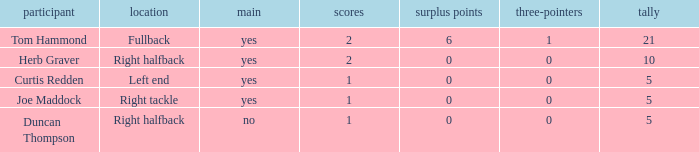I'm looking to parse the entire table for insights. Could you assist me with that? {'header': ['participant', 'location', 'main', 'scores', 'surplus points', 'three-pointers', 'tally'], 'rows': [['Tom Hammond', 'Fullback', 'yes', '2', '6', '1', '21'], ['Herb Graver', 'Right halfback', 'yes', '2', '0', '0', '10'], ['Curtis Redden', 'Left end', 'yes', '1', '0', '0', '5'], ['Joe Maddock', 'Right tackle', 'yes', '1', '0', '0', '5'], ['Duncan Thompson', 'Right halfback', 'no', '1', '0', '0', '5']]} Name the fewest touchdowns 1.0. 